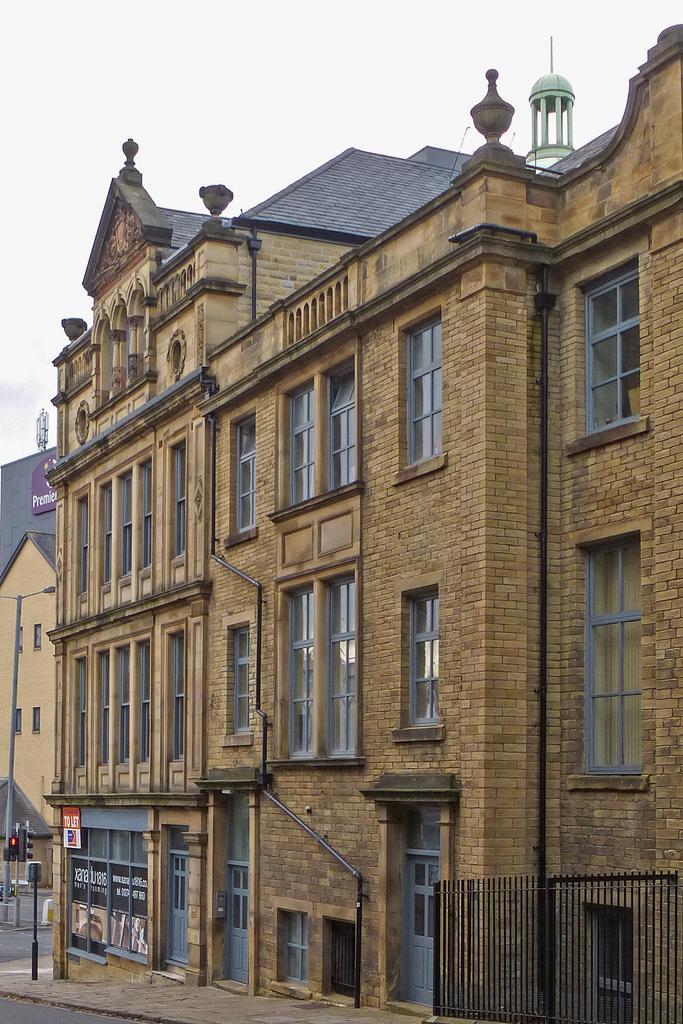Can you describe this image briefly? In this image we can see the fence, brick building, board to the pole, traffic signal poles, light poles and the sky in the background. 